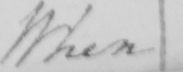What does this handwritten line say? When 